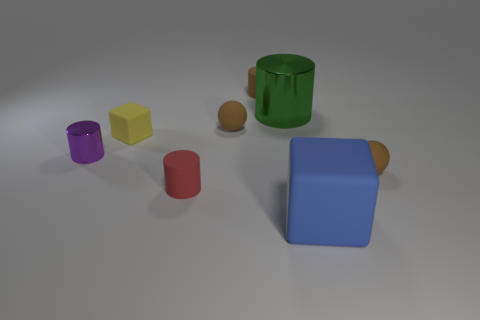Does the red matte cylinder have the same size as the green cylinder?
Provide a succinct answer. No. What number of other things are the same size as the purple shiny cylinder?
Your answer should be compact. 5. How many objects are either small brown rubber things to the right of the big blue block or small rubber cylinders that are behind the small red cylinder?
Provide a succinct answer. 2. There is a red object that is the same size as the yellow object; what is its shape?
Provide a short and direct response. Cylinder. There is a thing that is the same material as the large green cylinder; what size is it?
Provide a succinct answer. Small. Is the shape of the tiny red matte thing the same as the big shiny thing?
Offer a terse response. Yes. What color is the cube that is the same size as the green shiny object?
Offer a terse response. Blue. The brown matte object that is the same shape as the purple metal thing is what size?
Your answer should be compact. Small. The brown rubber object that is right of the large blue thing has what shape?
Offer a very short reply. Sphere. There is a purple thing; is it the same shape as the metallic thing right of the purple cylinder?
Your response must be concise. Yes. 